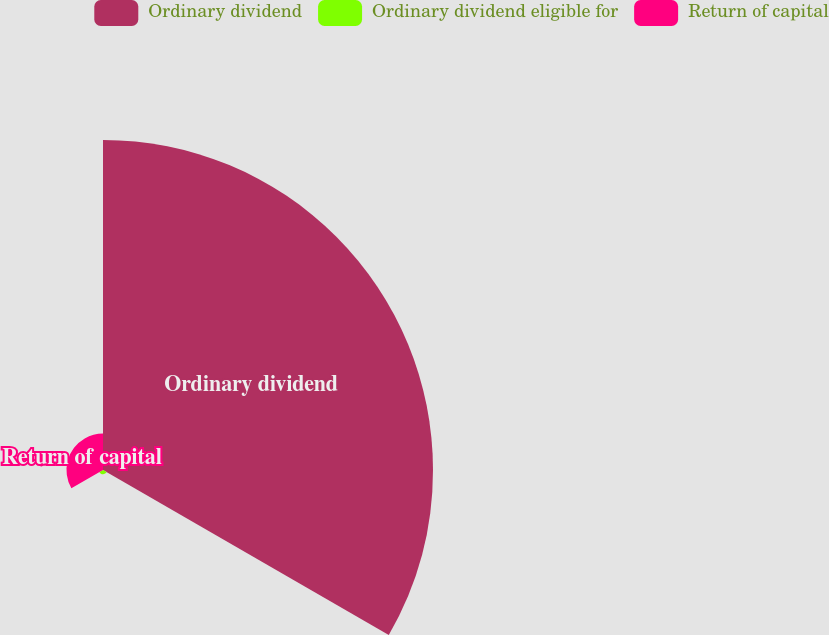Convert chart. <chart><loc_0><loc_0><loc_500><loc_500><pie_chart><fcel>Ordinary dividend<fcel>Ordinary dividend eligible for<fcel>Return of capital<nl><fcel>89.02%<fcel>1.14%<fcel>9.85%<nl></chart> 